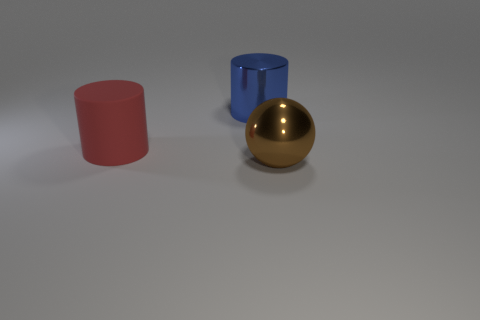Does the big object that is behind the big red matte cylinder have the same material as the ball?
Ensure brevity in your answer.  Yes. What material is the cylinder on the right side of the large rubber cylinder?
Ensure brevity in your answer.  Metal. What size is the thing that is on the left side of the shiny thing behind the rubber cylinder?
Keep it short and to the point. Large. Is there a small green object that has the same material as the big red thing?
Provide a short and direct response. No. There is a big shiny object that is behind the shiny thing in front of the large object behind the red matte cylinder; what shape is it?
Keep it short and to the point. Cylinder. There is a metal thing that is on the left side of the brown thing; is it the same color as the big object that is left of the large blue metal thing?
Offer a very short reply. No. Is there anything else that is the same size as the matte thing?
Your response must be concise. Yes. Are there any blue metallic things in front of the big matte thing?
Ensure brevity in your answer.  No. What number of other large objects are the same shape as the big red object?
Make the answer very short. 1. What color is the metallic thing that is on the left side of the big thing that is on the right side of the shiny thing that is to the left of the big brown shiny thing?
Provide a succinct answer. Blue. 